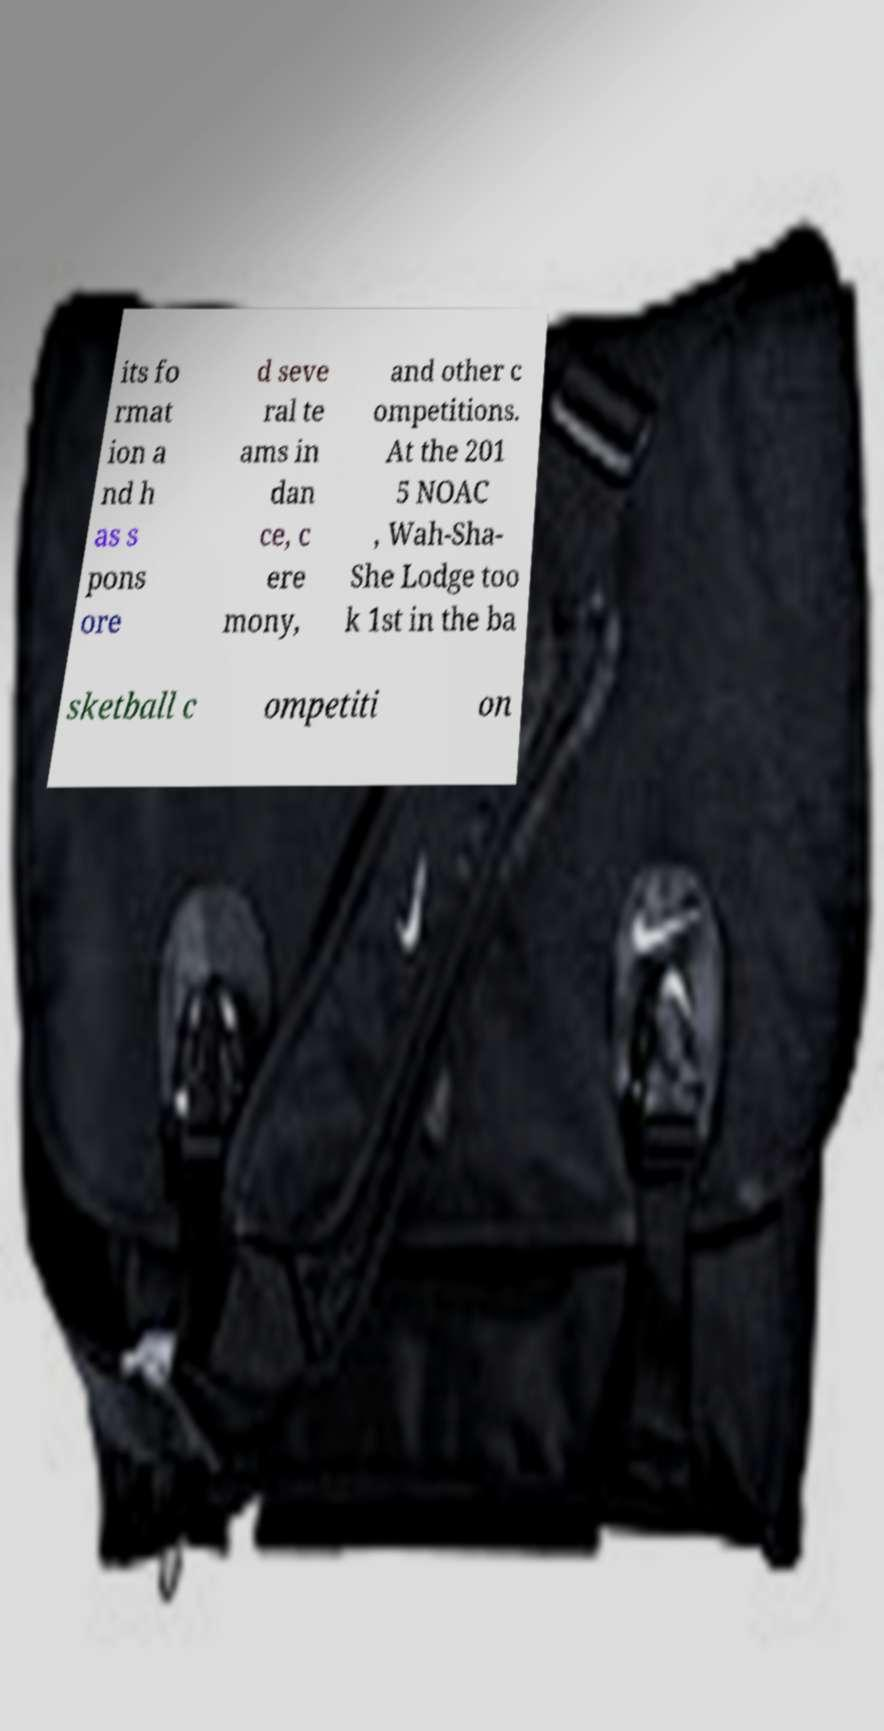Can you accurately transcribe the text from the provided image for me? its fo rmat ion a nd h as s pons ore d seve ral te ams in dan ce, c ere mony, and other c ompetitions. At the 201 5 NOAC , Wah-Sha- She Lodge too k 1st in the ba sketball c ompetiti on 